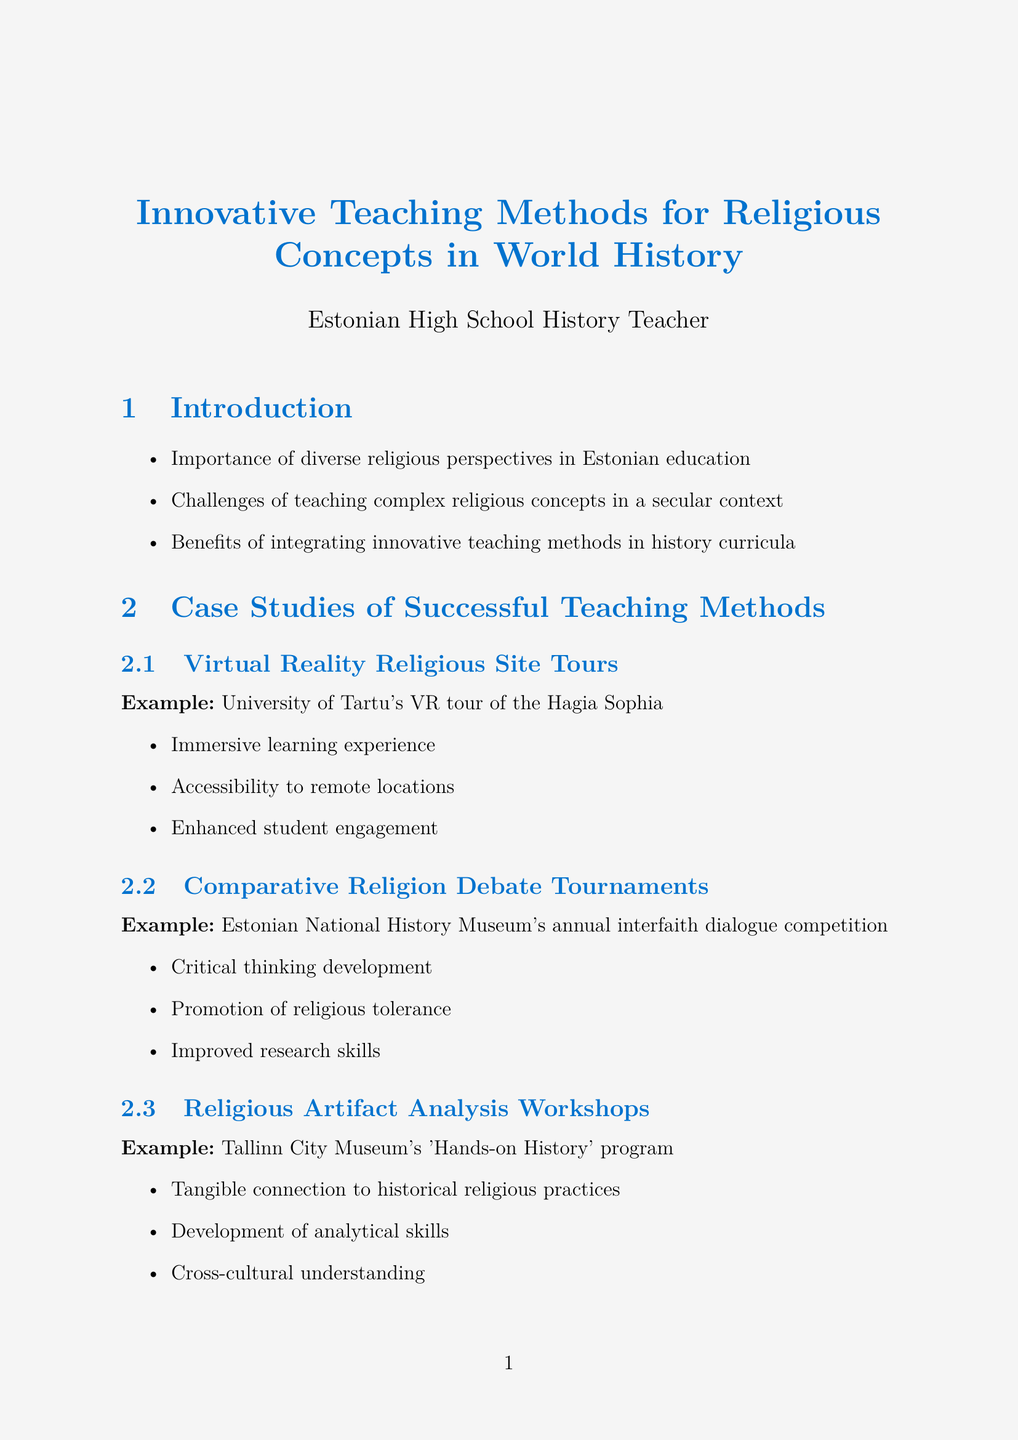What is the title of the document? The title of the document is presented at the beginning of the report and indicates the focus area of the content.
Answer: Innovative Teaching Methods for Religious Concepts in World History What innovative method utilizes virtual reality? The method is specifically described in the case studies section, highlighting a university initiative that uses advanced technology for education.
Answer: Virtual Reality Religious Site Tours Which museum hosts the interfaith dialogue competition? This information is found in the case studies, indicating a recognized venue for promoting religious discussions.
Answer: Estonian National History Museum What is one benefit of the "Religious Artifact Analysis Workshops"? Benefits of this innovative teaching method are listed, providing insights into its educational impact.
Answer: Tangible connection to historical religious practices What is the example project for digital storytelling? The document provides a specific example under the innovative assessment techniques section, illustrating the integration of technology in student projects.
Answer: Narva College's 'Voices of Faith' digital archive What approach helps maintain neutrality in discussing sensitive topics? This refers to guidelines presented for teachers in handling complex discussions regarding religion in the classroom context.
Answer: Guidelines for maintaining neutrality and respect Which tool is used for gamified assessments of religious facts? The document specifies different technological tools for education, highlighting one designed for quiz-based learning.
Answer: Kahoot! How many case studies of successful teaching methods are mentioned? The document lists specific case studies, reflecting the scope of innovative practices presented to readers.
Answer: Three 